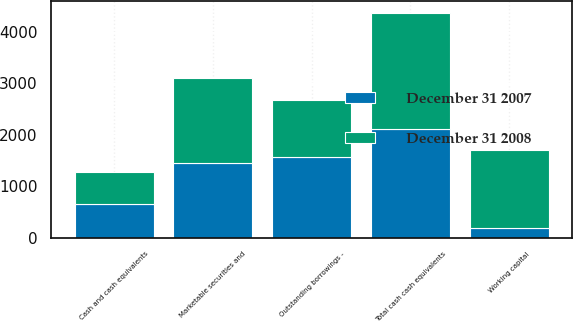Convert chart. <chart><loc_0><loc_0><loc_500><loc_500><stacked_bar_chart><ecel><fcel>Cash and cash equivalents<fcel>Marketable securities and<fcel>Total cash cash equivalents<fcel>Working capital<fcel>Outstanding borrowings -<nl><fcel>December 31 2008<fcel>622.4<fcel>1640.4<fcel>2262.8<fcel>1534.8<fcel>1113.1<nl><fcel>December 31 2007<fcel>659.7<fcel>1456.1<fcel>2115.8<fcel>179.2<fcel>1563<nl></chart> 